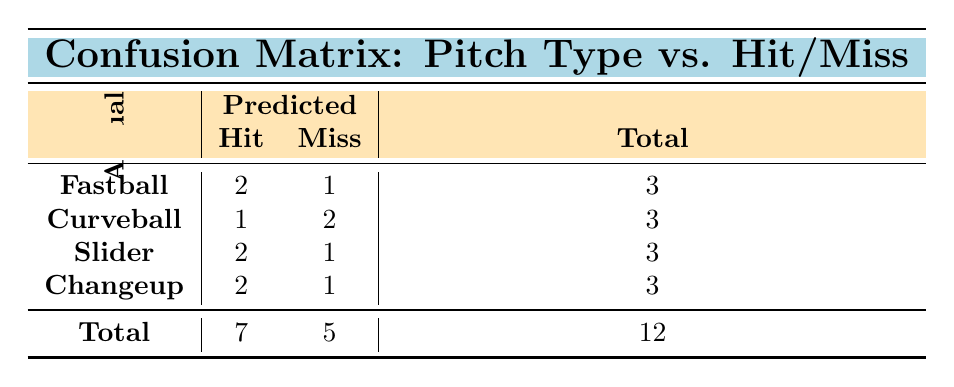What is the number of hits recorded for fastballs? The table shows that there are 2 hits recorded under the fastball category.
Answer: 2 What is the total number of misses across all pitch types? To find the total number of misses, we look at the "Miss" column: 1 (Fastball) + 2 (Curveball) + 1 (Slider) + 1 (Changeup) = 5.
Answer: 5 Is it true that the changeup pitch type had more hits than misses? The changeup has 2 hits and 1 miss, confirming that there were more hits than misses.
Answer: Yes What is the average number of hits per pitch type? There are a total of 7 hits across 4 pitch types. The average is calculated by dividing 7 by 4, which gives 1.75.
Answer: 1.75 Which pitch type had the highest number of predicted hits? From the table, both the fastball and slider pitch types each have 2 hits, which is the highest.
Answer: Fastball and Slider If a player hits a slider, what are the odds that it was a hit based on the data provided? The data shows 2 hits and 1 miss for the slider, giving a hit rate of 2 out of 3 attempts. The odds of hitting the slider is therefore 2 hits to 1 miss, or 2:1.
Answer: 2:1 Calculate the total number of predictions made for all pitch types. We can find the total by summing up the total column: 3 (Fastball) + 3 (Curveball) + 3 (Slider) + 3 (Changeup) = 12, which represents the total predictions.
Answer: 12 Did Emily Smith have more hits or misses overall? Emily recorded 3 hits (Curveball, Slider, Changeup) and 1 miss (Fastball), so she had more hits overall.
Answer: More hits How many pitch types did Michael Brown miss on? Michael Brown missed on the Curveball and Slider pitches, totaling 2 misses.
Answer: 2 